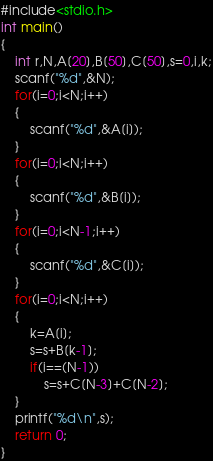Convert code to text. <code><loc_0><loc_0><loc_500><loc_500><_C_>#include<stdio.h>
int main()
{
    int r,N,A[20],B[50],C[50],s=0,i,k;
    scanf("%d",&N);
    for(i=0;i<N;i++)
    {
        scanf("%d",&A[i]);
    }
    for(i=0;i<N;i++)
    {
        scanf("%d",&B[i]);
    }
    for(i=0;i<N-1;i++)
    {
        scanf("%d",&C[i]);
    }
    for(i=0;i<N;i++)
    {
        k=A[i];
        s=s+B[k-1];
        if(i==(N-1))
            s=s+C[N-3]+C[N-2];
    }
    printf("%d\n",s);
    return 0;
}
</code> 